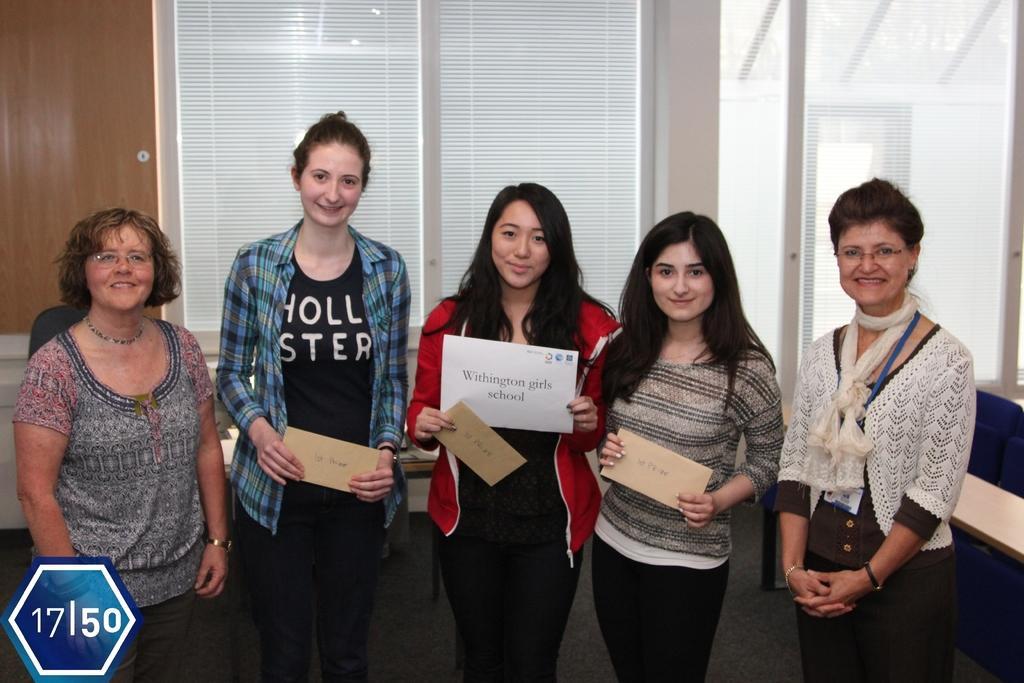Please provide a concise description of this image. This image is taken indoors. In the background there is door and there are a few windows with window blinds. On the right side of the image there is a couch. In the middle of the image five women are standing on the floor and three women are holding boards with text on them in their hands. 